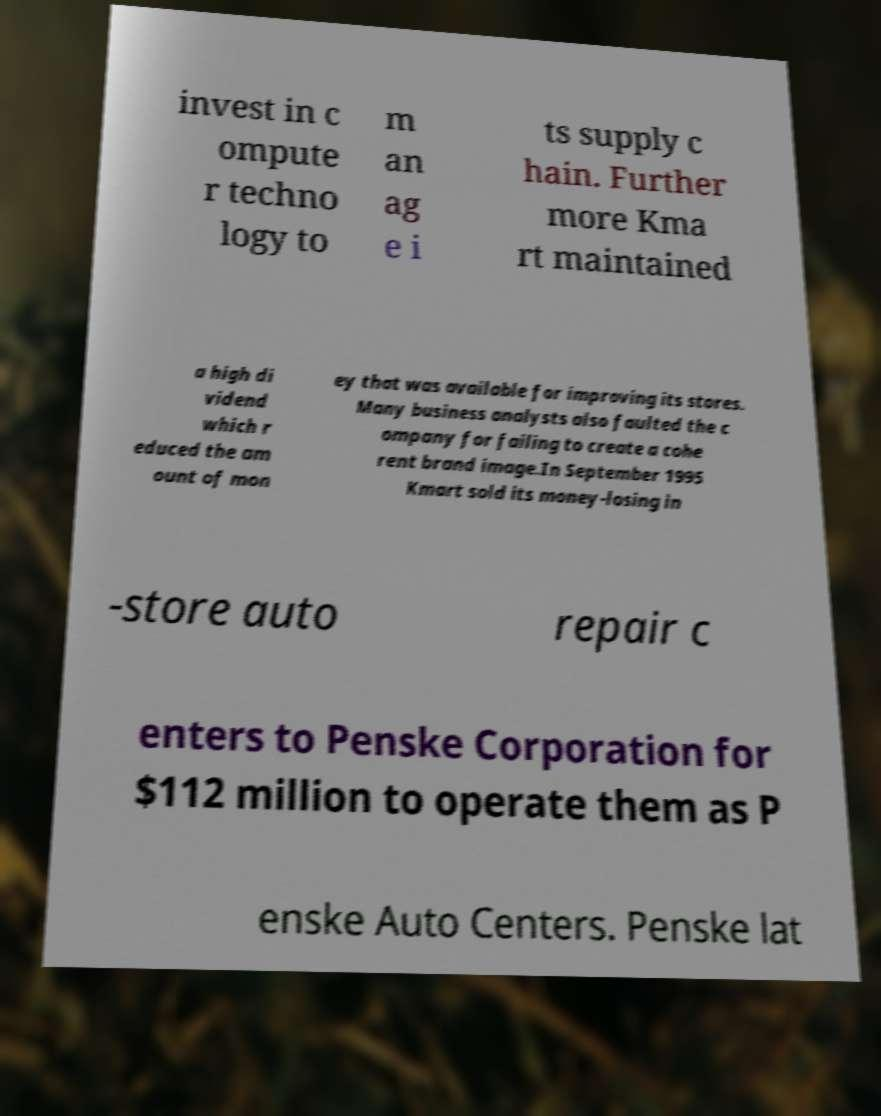Can you read and provide the text displayed in the image?This photo seems to have some interesting text. Can you extract and type it out for me? invest in c ompute r techno logy to m an ag e i ts supply c hain. Further more Kma rt maintained a high di vidend which r educed the am ount of mon ey that was available for improving its stores. Many business analysts also faulted the c ompany for failing to create a cohe rent brand image.In September 1995 Kmart sold its money-losing in -store auto repair c enters to Penske Corporation for $112 million to operate them as P enske Auto Centers. Penske lat 